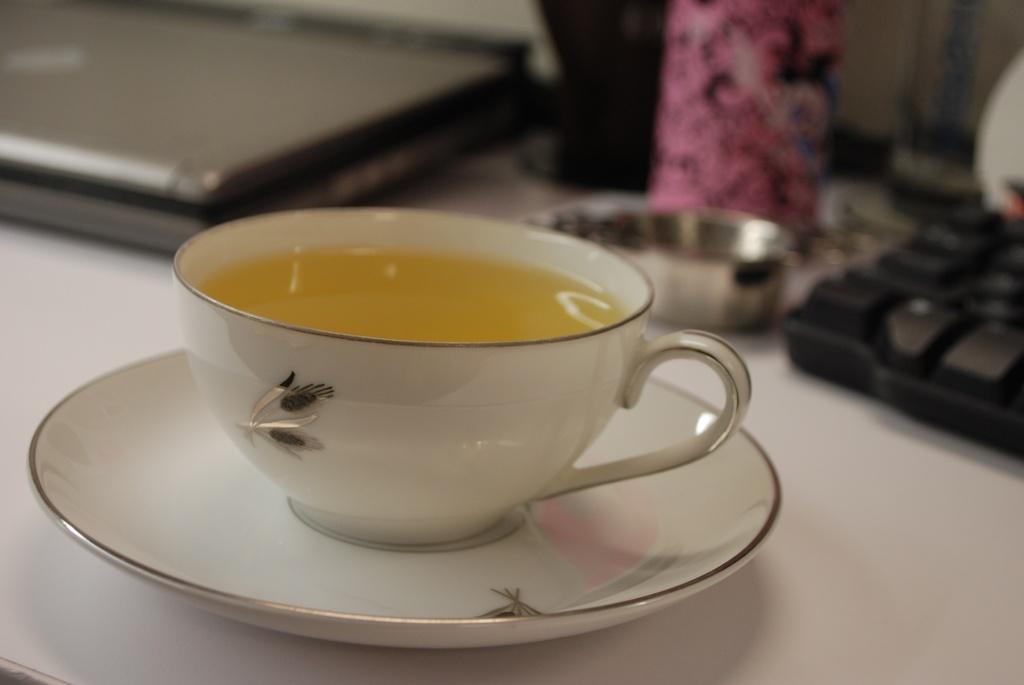Please provide a concise description of this image. In this image we can see a cup with liquid in it on a saucer on the table and we can also see laptop, objects and a keyboard. 